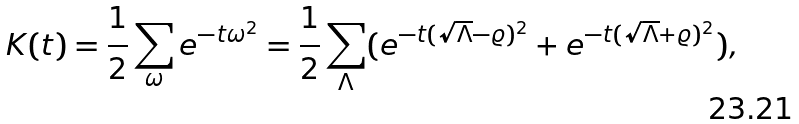Convert formula to latex. <formula><loc_0><loc_0><loc_500><loc_500>K ( t ) = \frac { 1 } { 2 } \sum _ { \omega } e ^ { - t \omega ^ { 2 } } = \frac { 1 } { 2 } \sum _ { \Lambda } ( e ^ { - t ( \sqrt { \Lambda } - \varrho ) ^ { 2 } } + e ^ { - t ( \sqrt { \Lambda } + \varrho ) ^ { 2 } } ) ,</formula> 